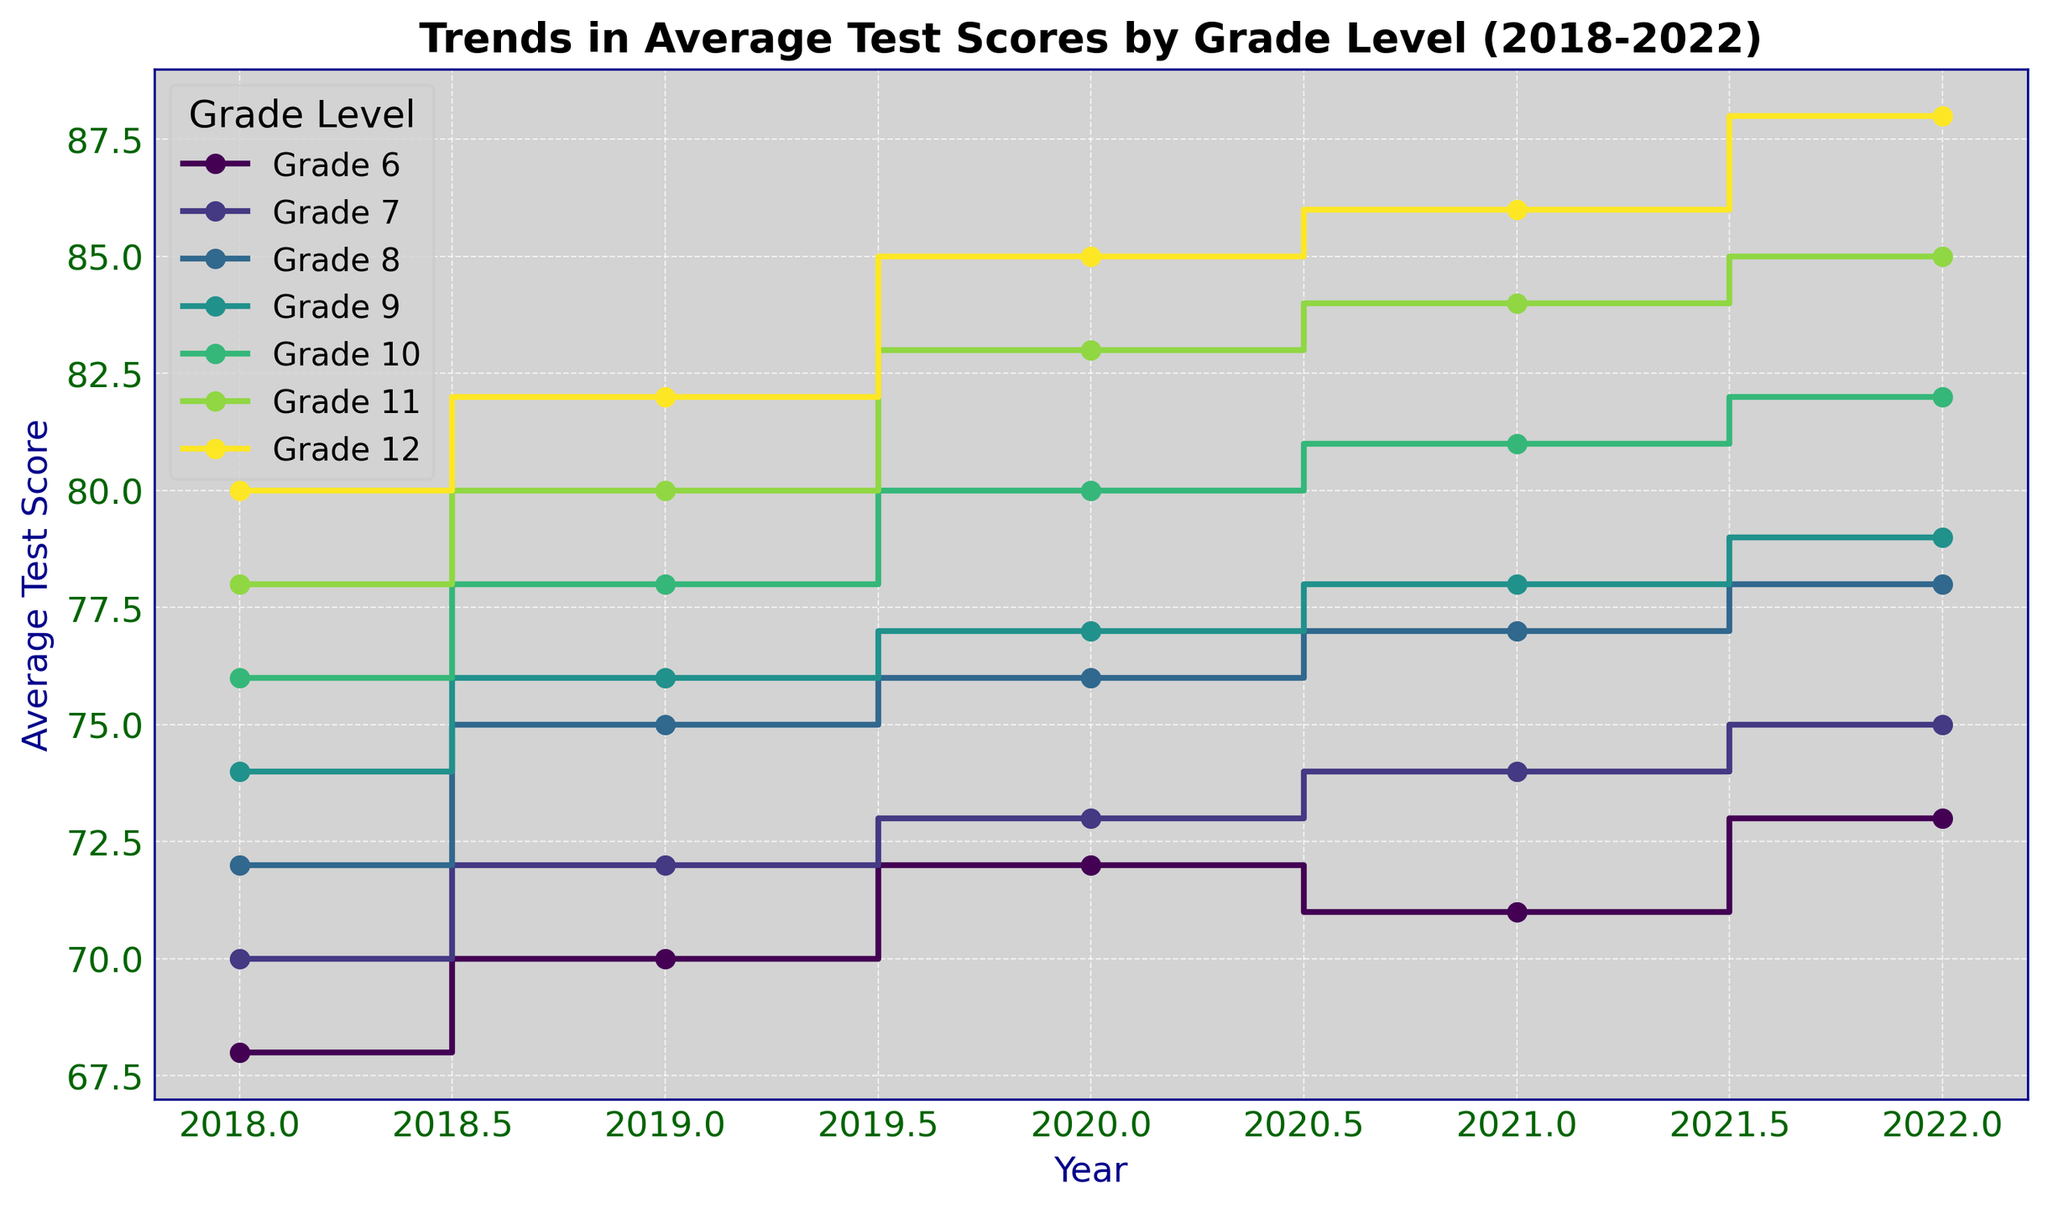What is the trend in average test scores for Grade 6 from 2018 to 2022? The average test scores for Grade 6 show an overall upward trend. The scores start at 68 in 2018 and rise to 73 in 2022, with slight fluctuations in between (71 in 2021).
Answer: Upward trend Which grade had the highest average test score in 2022? To determine the highest average test score in 2022, look at the endpoints of the plot lines for that year. Grade 12 had the highest test score, reaching 88.
Answer: Grade 12 Did any grade level see a decrease in average test scores in any given year? By carefully examining the steps for each grade, you can notice that Grade 6 had a slight decrease from 72 in 2020 to 71 in 2021.
Answer: Yes, Grade 6 Between grades 7 and 8, which grade showed a larger increase in average test scores from 2018 to 2022? Grade 7 went from 70 to 75 (an increase of 5), while Grade 8 went from 72 to 78 (an increase of 6). Therefore, Grade 8 showed a larger increase.
Answer: Grade 8 What is the average increase in test scores per year for Grade 10 from 2018 to 2022? Calculate the yearly differences: (78-76) + (80-78) + (81-80) + (82-81). There are four intervals, and summing these intervals gives 6. Therefore, the average increase per year is 6/5 = 1.2.
Answer: 1.2 Which two grades have the smallest difference in their average test scores in 2018? In 2018, the scores for the grades are: Grade 6 - 68, Grade 7 - 70, Grade 8 - 72, Grade 9 - 74, Grade 10 - 76, Grade 11 - 78, Grade 12 - 80. The smallest difference is between Grades 7 and 8, with a difference of 2.
Answer: Grades 7 and 8 How does the average test score of Grade 11 in 2021 compare to Grade 12 in 2018? The average test score for Grade 11 in 2021 is 84, and for Grade 12 in 2018 is 80. Comparing these, Grade 11 in 2021 has a higher score.
Answer: Higher Which grade levels have consistently increased their average test scores every year from 2018 to 2022? By examining the steps for each grade, Grades 8, 9, 10, 11, and 12 all show consistent yearly increases in their scores without any year-to-year decrease.
Answer: Grades 8, 9, 10, 11, and 12 